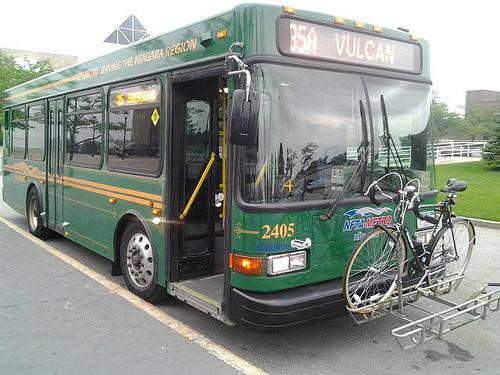Question: how many bikes?
Choices:
A. Two.
B. One.
C. Three.
D. Four.
Answer with the letter. Answer: B Question: how is the door to the bus positioned?
Choices:
A. Open.
B. Not closed.
C. Clear.
D. Ajar.
Answer with the letter. Answer: A Question: where is the bike?
Choices:
A. By the bus bumper.
B. On the bus rack.
C. In front of the bus.
D. Next to the headlight.
Answer with the letter. Answer: C Question: what color are the written numbers on the bus?
Choices:
A. Gold.
B. Silver.
C. Yellow.
D. Black.
Answer with the letter. Answer: A Question: what color are the rims?
Choices:
A. Black.
B. Red.
C. Silver.
D. Yellow.
Answer with the letter. Answer: C 